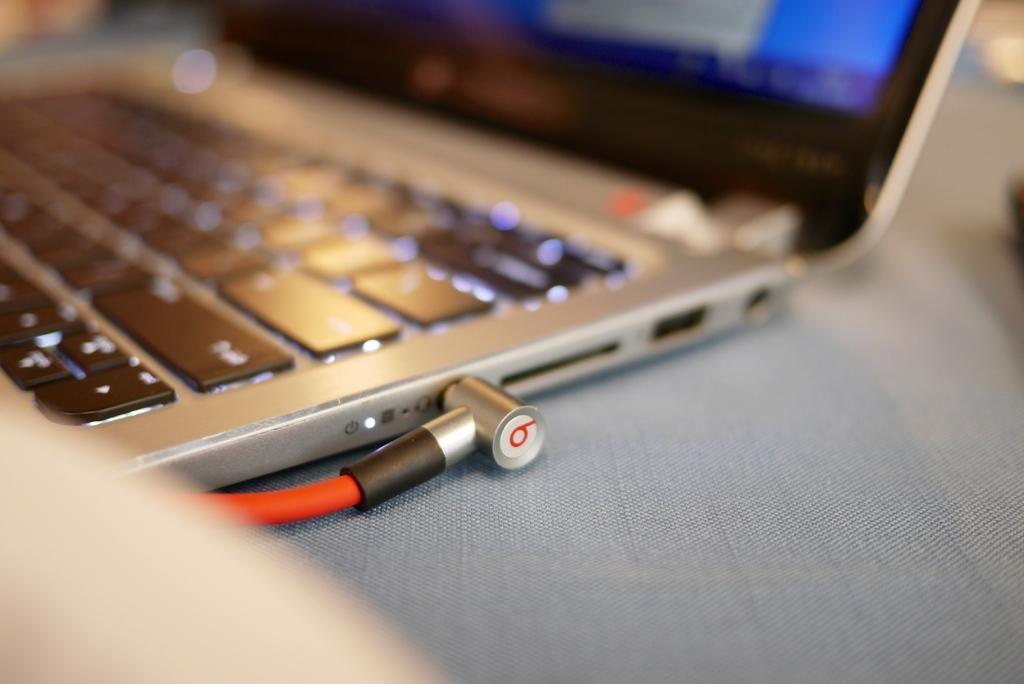<image>
Write a terse but informative summary of the picture. A blurry photo of the side of a laptop with beats earphones plugged in with the classic "b" on the end of the headphone jack. 